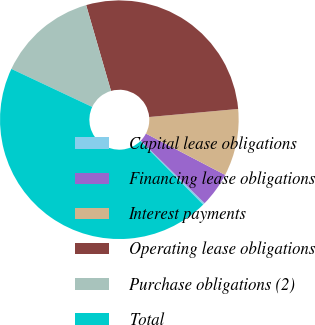Convert chart. <chart><loc_0><loc_0><loc_500><loc_500><pie_chart><fcel>Capital lease obligations<fcel>Financing lease obligations<fcel>Interest payments<fcel>Operating lease obligations<fcel>Purchase obligations (2)<fcel>Total<nl><fcel>0.27%<fcel>4.68%<fcel>9.09%<fcel>28.05%<fcel>13.51%<fcel>44.4%<nl></chart> 